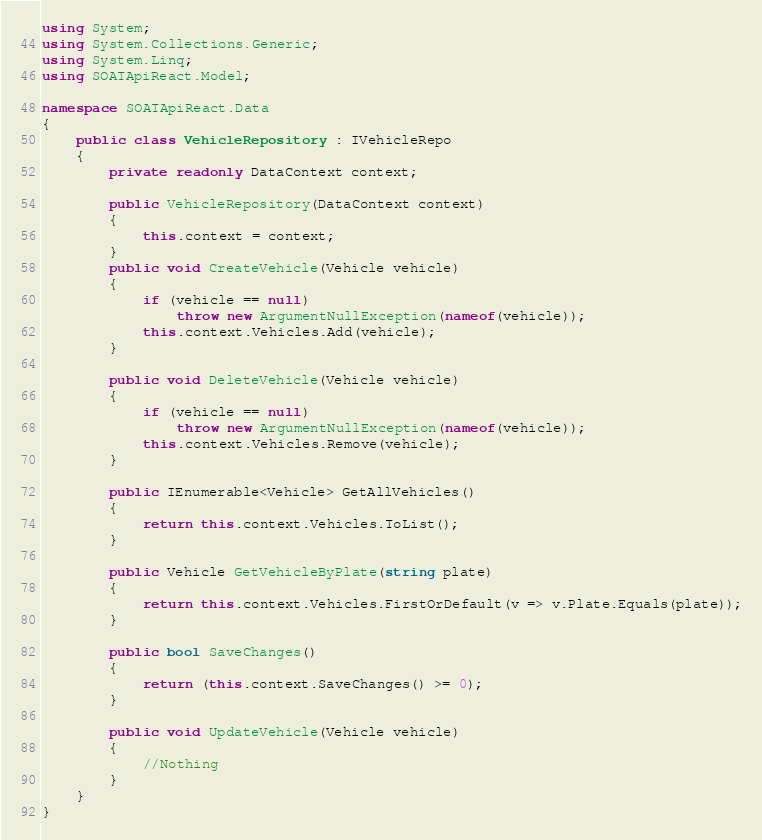<code> <loc_0><loc_0><loc_500><loc_500><_C#_>using System;
using System.Collections.Generic;
using System.Linq;
using SOATApiReact.Model;

namespace SOATApiReact.Data
{
    public class VehicleRepository : IVehicleRepo
    {
        private readonly DataContext context;

        public VehicleRepository(DataContext context)
        {
            this.context = context;
        }
        public void CreateVehicle(Vehicle vehicle)
        {
            if (vehicle == null)
                throw new ArgumentNullException(nameof(vehicle));
            this.context.Vehicles.Add(vehicle);
        }

        public void DeleteVehicle(Vehicle vehicle)
        {
            if (vehicle == null)
                throw new ArgumentNullException(nameof(vehicle));
            this.context.Vehicles.Remove(vehicle);
        }

        public IEnumerable<Vehicle> GetAllVehicles()
        {
            return this.context.Vehicles.ToList();
        }

        public Vehicle GetVehicleByPlate(string plate)
        {
            return this.context.Vehicles.FirstOrDefault(v => v.Plate.Equals(plate));
        }

        public bool SaveChanges()
        {
            return (this.context.SaveChanges() >= 0);
        }

        public void UpdateVehicle(Vehicle vehicle)
        {
            //Nothing
        }
    }
}</code> 